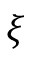<formula> <loc_0><loc_0><loc_500><loc_500>\xi</formula> 